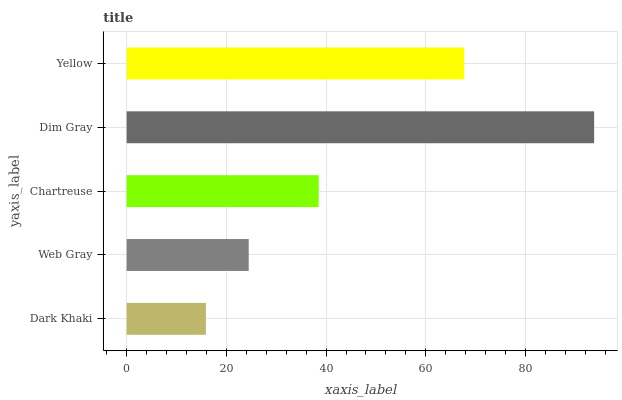Is Dark Khaki the minimum?
Answer yes or no. Yes. Is Dim Gray the maximum?
Answer yes or no. Yes. Is Web Gray the minimum?
Answer yes or no. No. Is Web Gray the maximum?
Answer yes or no. No. Is Web Gray greater than Dark Khaki?
Answer yes or no. Yes. Is Dark Khaki less than Web Gray?
Answer yes or no. Yes. Is Dark Khaki greater than Web Gray?
Answer yes or no. No. Is Web Gray less than Dark Khaki?
Answer yes or no. No. Is Chartreuse the high median?
Answer yes or no. Yes. Is Chartreuse the low median?
Answer yes or no. Yes. Is Web Gray the high median?
Answer yes or no. No. Is Dim Gray the low median?
Answer yes or no. No. 